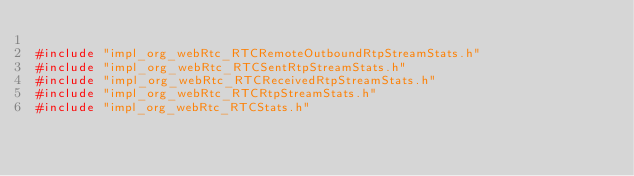<code> <loc_0><loc_0><loc_500><loc_500><_C++_>
#include "impl_org_webRtc_RTCRemoteOutboundRtpStreamStats.h"
#include "impl_org_webRtc_RTCSentRtpStreamStats.h"
#include "impl_org_webRtc_RTCReceivedRtpStreamStats.h"
#include "impl_org_webRtc_RTCRtpStreamStats.h"
#include "impl_org_webRtc_RTCStats.h"
</code> 